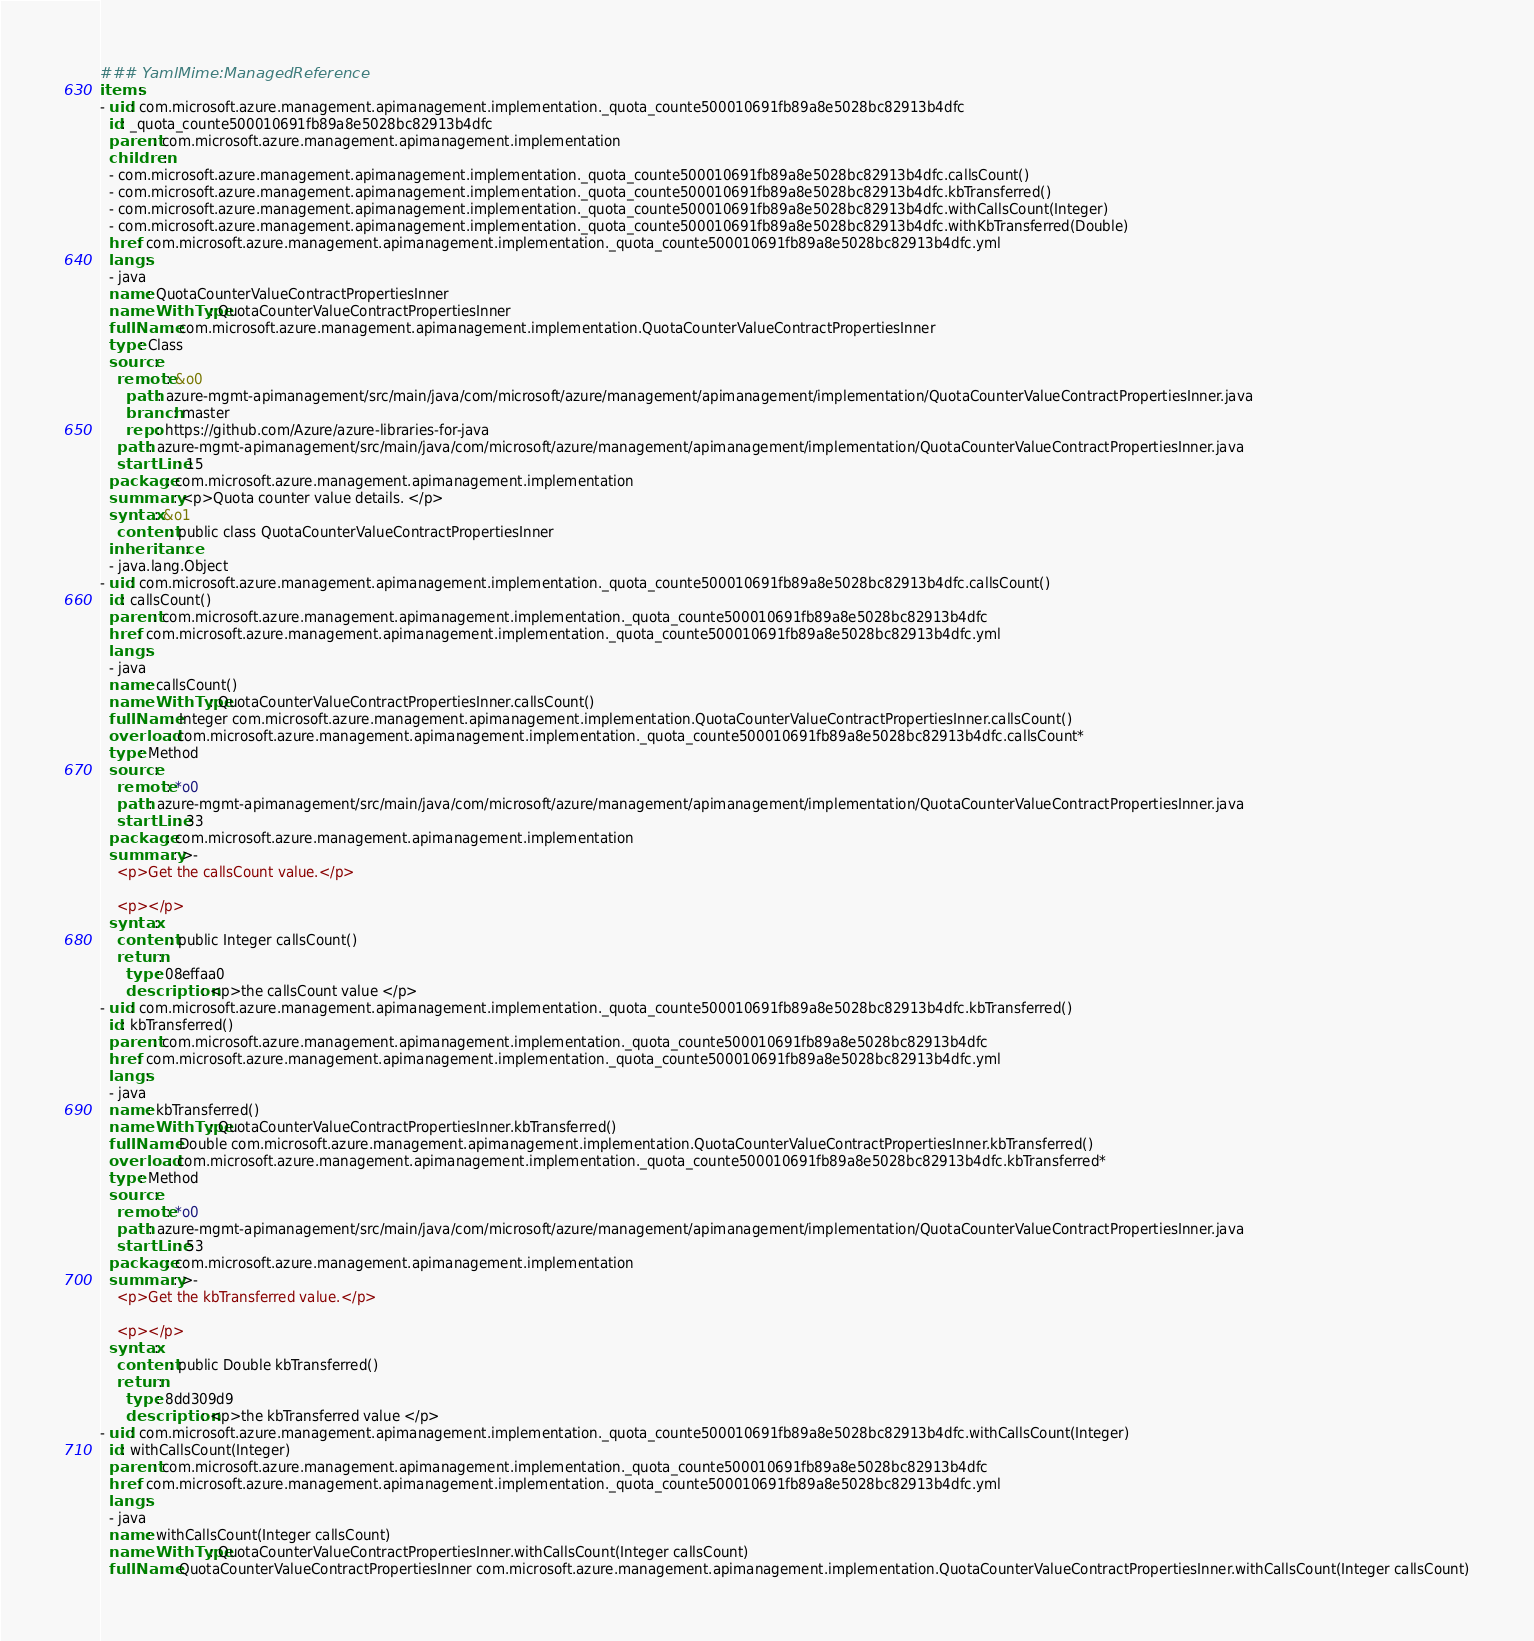<code> <loc_0><loc_0><loc_500><loc_500><_YAML_>### YamlMime:ManagedReference
items:
- uid: com.microsoft.azure.management.apimanagement.implementation._quota_counte500010691fb89a8e5028bc82913b4dfc
  id: _quota_counte500010691fb89a8e5028bc82913b4dfc
  parent: com.microsoft.azure.management.apimanagement.implementation
  children:
  - com.microsoft.azure.management.apimanagement.implementation._quota_counte500010691fb89a8e5028bc82913b4dfc.callsCount()
  - com.microsoft.azure.management.apimanagement.implementation._quota_counte500010691fb89a8e5028bc82913b4dfc.kbTransferred()
  - com.microsoft.azure.management.apimanagement.implementation._quota_counte500010691fb89a8e5028bc82913b4dfc.withCallsCount(Integer)
  - com.microsoft.azure.management.apimanagement.implementation._quota_counte500010691fb89a8e5028bc82913b4dfc.withKbTransferred(Double)
  href: com.microsoft.azure.management.apimanagement.implementation._quota_counte500010691fb89a8e5028bc82913b4dfc.yml
  langs:
  - java
  name: QuotaCounterValueContractPropertiesInner
  nameWithType: QuotaCounterValueContractPropertiesInner
  fullName: com.microsoft.azure.management.apimanagement.implementation.QuotaCounterValueContractPropertiesInner
  type: Class
  source:
    remote: &o0
      path: azure-mgmt-apimanagement/src/main/java/com/microsoft/azure/management/apimanagement/implementation/QuotaCounterValueContractPropertiesInner.java
      branch: master
      repo: https://github.com/Azure/azure-libraries-for-java
    path: azure-mgmt-apimanagement/src/main/java/com/microsoft/azure/management/apimanagement/implementation/QuotaCounterValueContractPropertiesInner.java
    startLine: 15
  package: com.microsoft.azure.management.apimanagement.implementation
  summary: <p>Quota counter value details. </p>
  syntax: &o1
    content: public class QuotaCounterValueContractPropertiesInner
  inheritance:
  - java.lang.Object
- uid: com.microsoft.azure.management.apimanagement.implementation._quota_counte500010691fb89a8e5028bc82913b4dfc.callsCount()
  id: callsCount()
  parent: com.microsoft.azure.management.apimanagement.implementation._quota_counte500010691fb89a8e5028bc82913b4dfc
  href: com.microsoft.azure.management.apimanagement.implementation._quota_counte500010691fb89a8e5028bc82913b4dfc.yml
  langs:
  - java
  name: callsCount()
  nameWithType: QuotaCounterValueContractPropertiesInner.callsCount()
  fullName: Integer com.microsoft.azure.management.apimanagement.implementation.QuotaCounterValueContractPropertiesInner.callsCount()
  overload: com.microsoft.azure.management.apimanagement.implementation._quota_counte500010691fb89a8e5028bc82913b4dfc.callsCount*
  type: Method
  source:
    remote: *o0
    path: azure-mgmt-apimanagement/src/main/java/com/microsoft/azure/management/apimanagement/implementation/QuotaCounterValueContractPropertiesInner.java
    startLine: 33
  package: com.microsoft.azure.management.apimanagement.implementation
  summary: >-
    <p>Get the callsCount value.</p>

    <p></p>
  syntax:
    content: public Integer callsCount()
    return:
      type: 08effaa0
      description: <p>the callsCount value </p>
- uid: com.microsoft.azure.management.apimanagement.implementation._quota_counte500010691fb89a8e5028bc82913b4dfc.kbTransferred()
  id: kbTransferred()
  parent: com.microsoft.azure.management.apimanagement.implementation._quota_counte500010691fb89a8e5028bc82913b4dfc
  href: com.microsoft.azure.management.apimanagement.implementation._quota_counte500010691fb89a8e5028bc82913b4dfc.yml
  langs:
  - java
  name: kbTransferred()
  nameWithType: QuotaCounterValueContractPropertiesInner.kbTransferred()
  fullName: Double com.microsoft.azure.management.apimanagement.implementation.QuotaCounterValueContractPropertiesInner.kbTransferred()
  overload: com.microsoft.azure.management.apimanagement.implementation._quota_counte500010691fb89a8e5028bc82913b4dfc.kbTransferred*
  type: Method
  source:
    remote: *o0
    path: azure-mgmt-apimanagement/src/main/java/com/microsoft/azure/management/apimanagement/implementation/QuotaCounterValueContractPropertiesInner.java
    startLine: 53
  package: com.microsoft.azure.management.apimanagement.implementation
  summary: >-
    <p>Get the kbTransferred value.</p>

    <p></p>
  syntax:
    content: public Double kbTransferred()
    return:
      type: 8dd309d9
      description: <p>the kbTransferred value </p>
- uid: com.microsoft.azure.management.apimanagement.implementation._quota_counte500010691fb89a8e5028bc82913b4dfc.withCallsCount(Integer)
  id: withCallsCount(Integer)
  parent: com.microsoft.azure.management.apimanagement.implementation._quota_counte500010691fb89a8e5028bc82913b4dfc
  href: com.microsoft.azure.management.apimanagement.implementation._quota_counte500010691fb89a8e5028bc82913b4dfc.yml
  langs:
  - java
  name: withCallsCount(Integer callsCount)
  nameWithType: QuotaCounterValueContractPropertiesInner.withCallsCount(Integer callsCount)
  fullName: QuotaCounterValueContractPropertiesInner com.microsoft.azure.management.apimanagement.implementation.QuotaCounterValueContractPropertiesInner.withCallsCount(Integer callsCount)</code> 